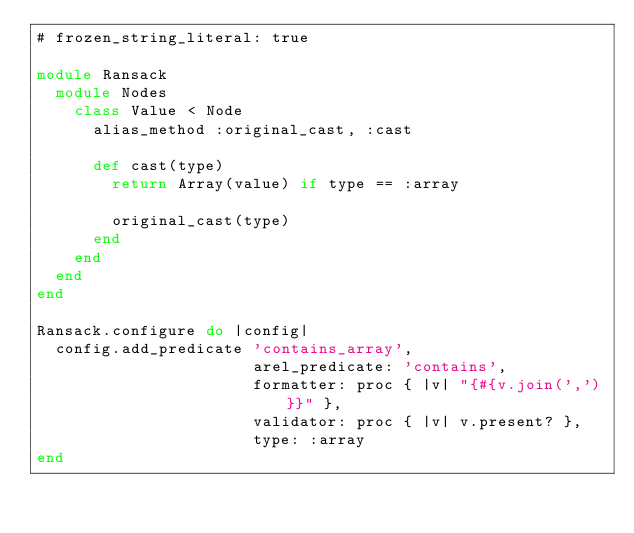Convert code to text. <code><loc_0><loc_0><loc_500><loc_500><_Ruby_># frozen_string_literal: true

module Ransack
  module Nodes
    class Value < Node
      alias_method :original_cast, :cast

      def cast(type)
        return Array(value) if type == :array

        original_cast(type)
      end
    end
  end
end

Ransack.configure do |config|
  config.add_predicate 'contains_array',
                       arel_predicate: 'contains',
                       formatter: proc { |v| "{#{v.join(',')}}" },
                       validator: proc { |v| v.present? },
                       type: :array
end
</code> 